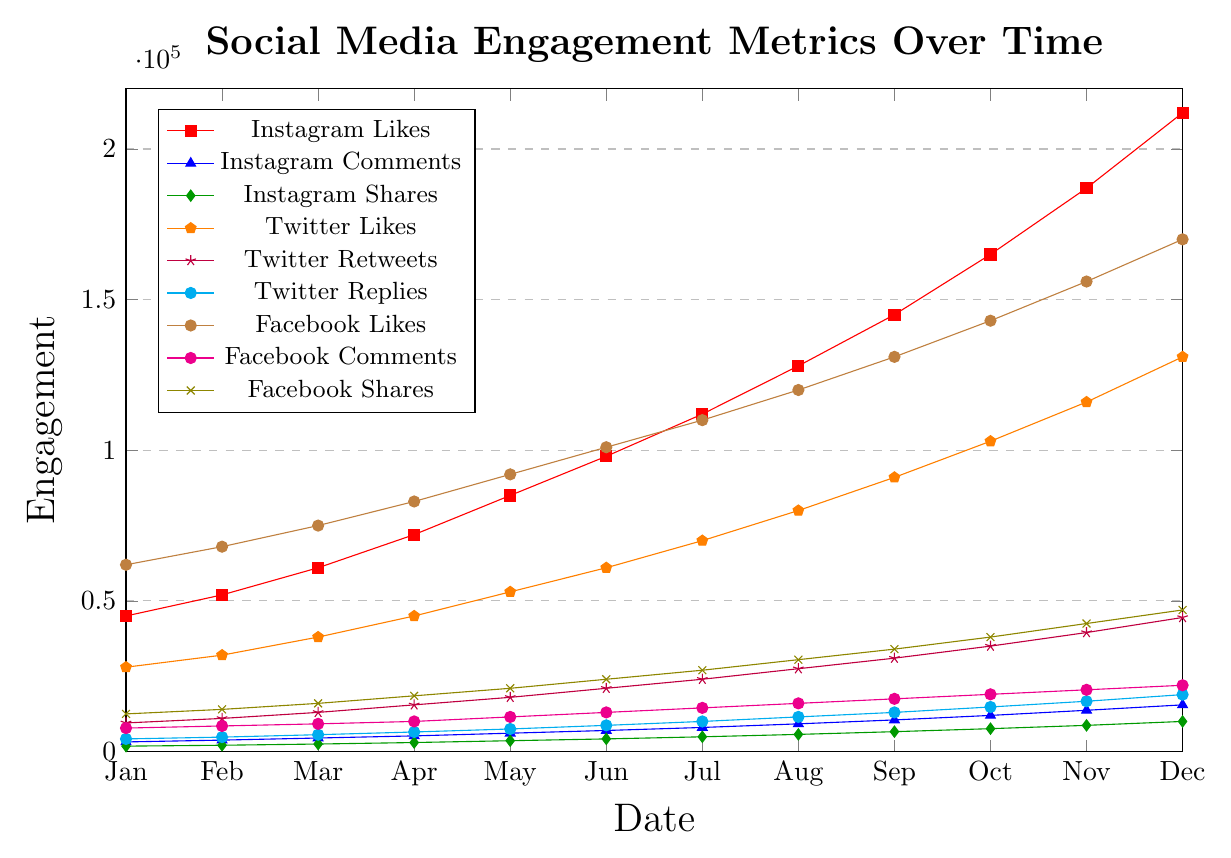Which social media platform had the highest number of likes in December? In the figure, December is the last month on the x-axis. Observe the values for "Instagram Likes," "Twitter Likes," and "Facebook Likes," and note the highest one. Instagram Likes are 212,000, Twitter Likes are 131,000, and Facebook Likes are 170,000.
Answer: Instagram What is the difference between Instagram Comments and Facebook Comments in November? For November, locate the values for "Instagram Comments" and "Facebook Comments" based on their respective legend entries and colors. For Instagram Comments, the value is 13,700, and for Facebook Comments, it is 20,500. Calculate the difference: 20,500 - 13,700 = 6,800.
Answer: 6,800 How much did Twitter Retweets increase from January to December? Find the values for "Twitter Retweets" in January and December. According to the figure, January has 9,500 retweets, and December has 44,500. Calculate the increase: 44,500 - 9,500 = 35,000.
Answer: 35,000 Which engagement metric shows consistent growth throughout the year? Observe the general trend of each line plotted for different engagement metrics. "Instagram Likes" shows consistent growth as the line continuously moves upward from January to December.
Answer: Instagram Likes By how much did Instagram Shares grow from April to October? Identify the values of "Instagram Shares" in April (3,000) and October (7,600). Compute the growth by subtracting April's value from October's: 7,600 - 3,000 = 4,600.
Answer: 4,600 Did Facebook Likes surpass 100,000 at any point during the year, and if so, when? Follow the "Facebook Likes" line on the plot and note the month where it crosses the 100,000 mark, which occurs between May and June. The value surpasses 100,000 as of June.
Answer: June Which month saw the highest number of Twitter Replies? Look at the "Twitter Replies" entries on the plot and observe the maxima. The highest point, which is in December, has a value of 18,900.
Answer: December Compare the growth rate of Instagram Likes and Facebook Likes over the year. Which one had a steeper increase? Analyze the slopes of the lines for "Instagram Likes" and "Facebook Likes." "Instagram Likes" started at 45,000 and reached 212,000 (an increase of 167,000), while "Facebook Likes" started at 62,000 and reached 170,000 (an increase of 108,000). The steeper slope corresponds to a higher increase of Instagram Likes.
Answer: Instagram Likes What is the sum of shares across all three social media platforms in June? Identify the individual values for shares: Instagram Shares (4,200), Twitter Retweets (21,000), and Facebook Shares (24,000). Sum these values: 4,200 + 21,000 + 24,000 = 49,200.
Answer: 49,200 